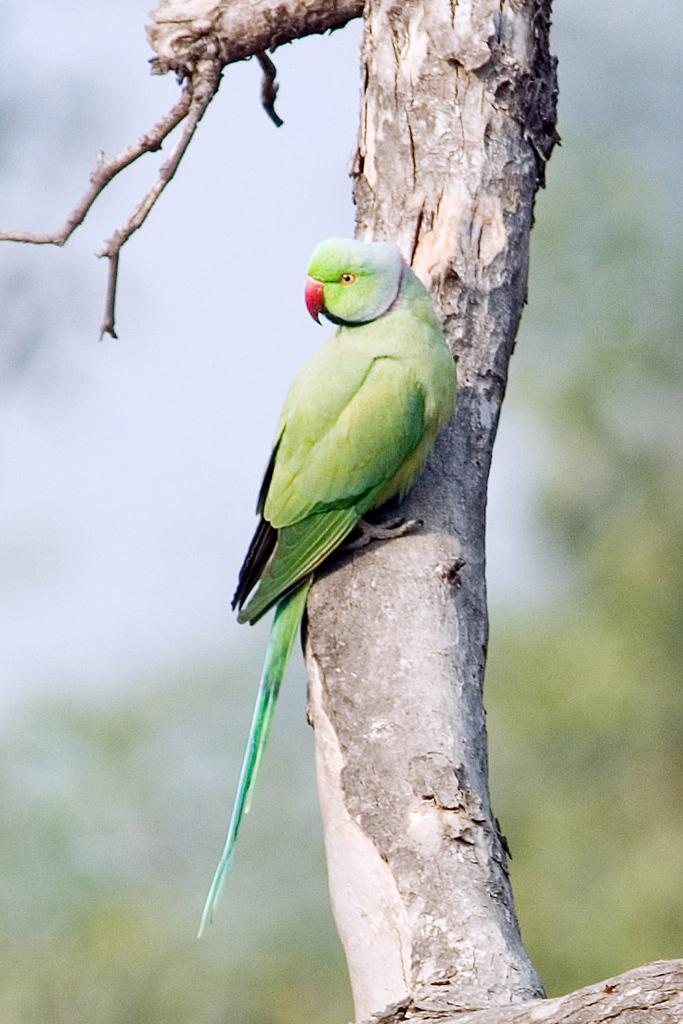What type of animal is in the image? There is a parrot in the image. Where is the parrot located? The parrot is on a tree. What color is the parrot? The parrot is green in color. Can you describe the background of the image? The background of the image is blurred. What type of metal is the parrot using to clean its feathers in the image? There is no metal object present in the image, and the parrot is not cleaning its feathers. 